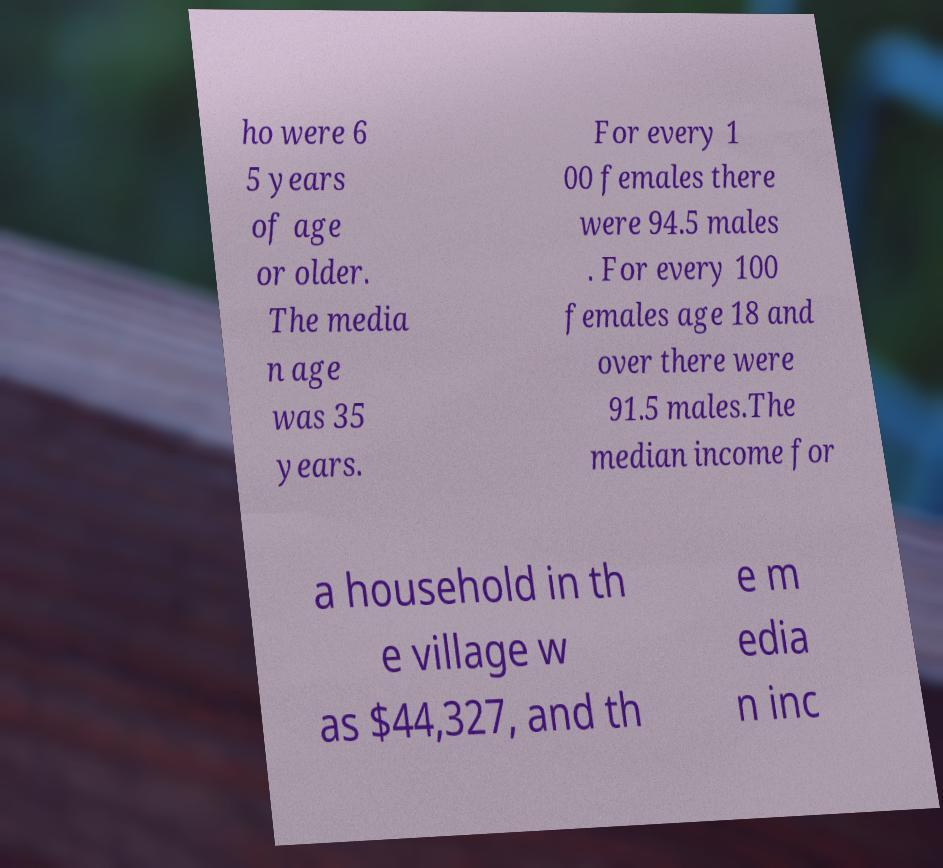There's text embedded in this image that I need extracted. Can you transcribe it verbatim? ho were 6 5 years of age or older. The media n age was 35 years. For every 1 00 females there were 94.5 males . For every 100 females age 18 and over there were 91.5 males.The median income for a household in th e village w as $44,327, and th e m edia n inc 